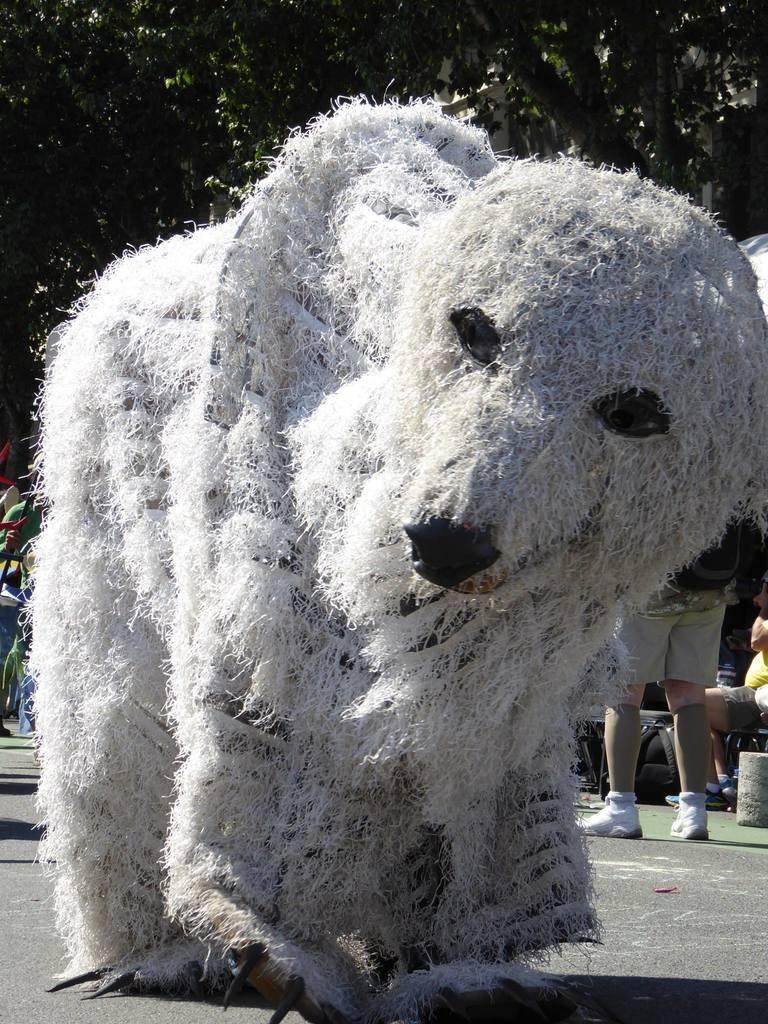What type of object is the main subject of the image? There is a white color animal statue in the image. Can you describe the setting of the image? There is a person standing in the background of the image, and there are green color trees in the background as well. What type of organization is depicted in the image? There is no organization depicted in the image; it features a white color animal statue, a person standing in the background, and green color trees. Can you tell me how many owls are sitting on the branches of the trees in the image? There are no owls present in the image; it only features a white color animal statue, a person standing in the background, and green color trees. 